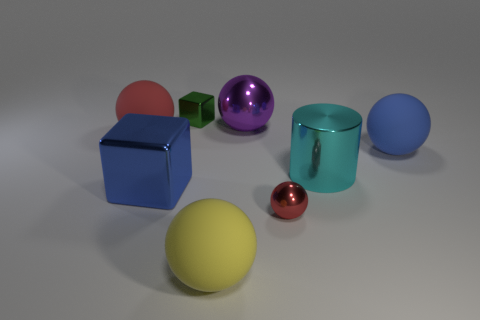What number of large things are either yellow things or gray matte cylinders?
Provide a short and direct response. 1. What is the size of the red thing that is to the right of the red ball that is left of the matte ball in front of the big blue matte sphere?
Give a very brief answer. Small. Is there any other thing that has the same color as the big cube?
Your response must be concise. Yes. There is a tiny thing that is on the left side of the tiny object right of the yellow ball that is in front of the big blue shiny thing; what is it made of?
Give a very brief answer. Metal. Is the shape of the green thing the same as the purple object?
Your answer should be very brief. No. Is there any other thing that is made of the same material as the big red ball?
Offer a terse response. Yes. How many spheres are both behind the cyan thing and right of the purple sphere?
Give a very brief answer. 1. The big shiny thing behind the big ball that is left of the tiny green metallic block is what color?
Provide a succinct answer. Purple. Are there an equal number of big balls that are behind the large red matte sphere and green cubes?
Offer a very short reply. Yes. What number of blocks are behind the large cylinder that is on the right side of the tiny metallic sphere left of the large cyan metal thing?
Your answer should be compact. 1. 